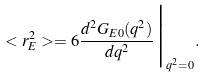<formula> <loc_0><loc_0><loc_500><loc_500>< r _ { E } ^ { 2 } > = 6 \frac { d ^ { 2 } G _ { E 0 } ( q ^ { 2 } ) } { d q ^ { 2 } } \Big | _ { q ^ { 2 } = 0 } .</formula> 